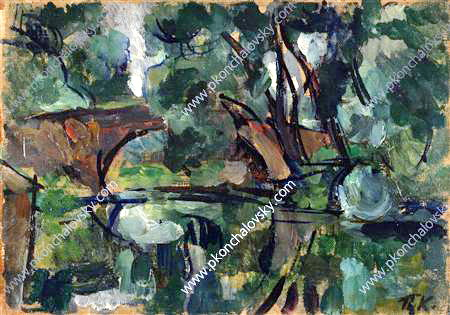What do you think is going on in this snapshot? This image is a captivating depiction of a natural landscape, executed in a post-impressionist style. The scenery is dominated by a tranquil pond, surrounded by verdant trees and dense shrubs. The color palette mainly features soothing greens and blues, with strategic accents of brown and black to provide depth and contrast, enriching the visual appeal. The artist's loose and dynamic brushwork breathes life into the composition, imbuing the static natural elements with a sense of movement and vitality. This piece exemplifies the essence of the post-impressionist movement, where artists utilize color and technique not just to represent the physical world, but also to express their emotional and aesthetic experiences. The reflective surface of the pond and the interplay of natural light create a harmonious and immersive scene that invites viewers to linger and explore its nuances. 